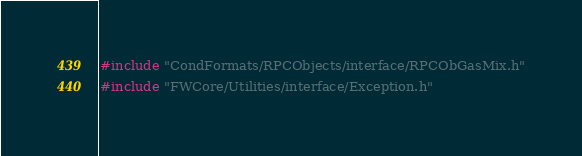Convert code to text. <code><loc_0><loc_0><loc_500><loc_500><_C++_>#include "CondFormats/RPCObjects/interface/RPCObGasMix.h"
#include "FWCore/Utilities/interface/Exception.h"
</code> 